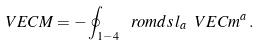Convert formula to latex. <formula><loc_0><loc_0><loc_500><loc_500>\ V E C M = - \oint _ { 1 - 4 } \, \ r o m d s \, l _ { a } \ V E C m ^ { a } \, .</formula> 